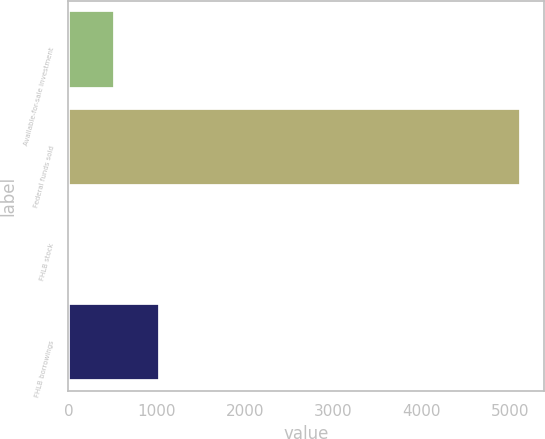Convert chart to OTSL. <chart><loc_0><loc_0><loc_500><loc_500><bar_chart><fcel>Available-for-sale investment<fcel>Federal funds sold<fcel>FHLB stock<fcel>FHLB borrowings<nl><fcel>526.1<fcel>5126<fcel>15<fcel>1037.2<nl></chart> 